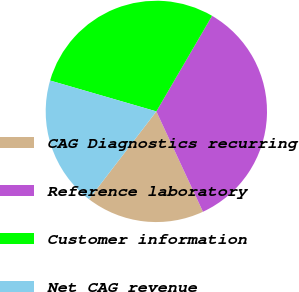<chart> <loc_0><loc_0><loc_500><loc_500><pie_chart><fcel>CAG Diagnostics recurring<fcel>Reference laboratory<fcel>Customer information<fcel>Net CAG revenue<nl><fcel>17.34%<fcel>34.68%<fcel>28.9%<fcel>19.08%<nl></chart> 